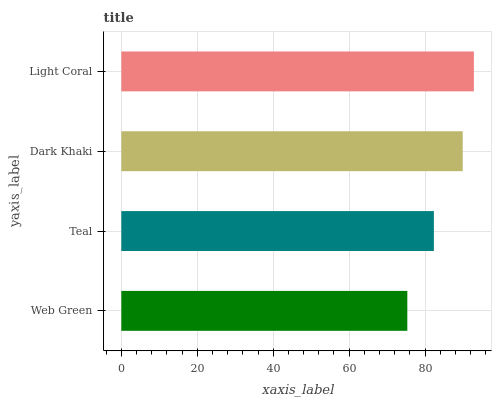Is Web Green the minimum?
Answer yes or no. Yes. Is Light Coral the maximum?
Answer yes or no. Yes. Is Teal the minimum?
Answer yes or no. No. Is Teal the maximum?
Answer yes or no. No. Is Teal greater than Web Green?
Answer yes or no. Yes. Is Web Green less than Teal?
Answer yes or no. Yes. Is Web Green greater than Teal?
Answer yes or no. No. Is Teal less than Web Green?
Answer yes or no. No. Is Dark Khaki the high median?
Answer yes or no. Yes. Is Teal the low median?
Answer yes or no. Yes. Is Web Green the high median?
Answer yes or no. No. Is Light Coral the low median?
Answer yes or no. No. 